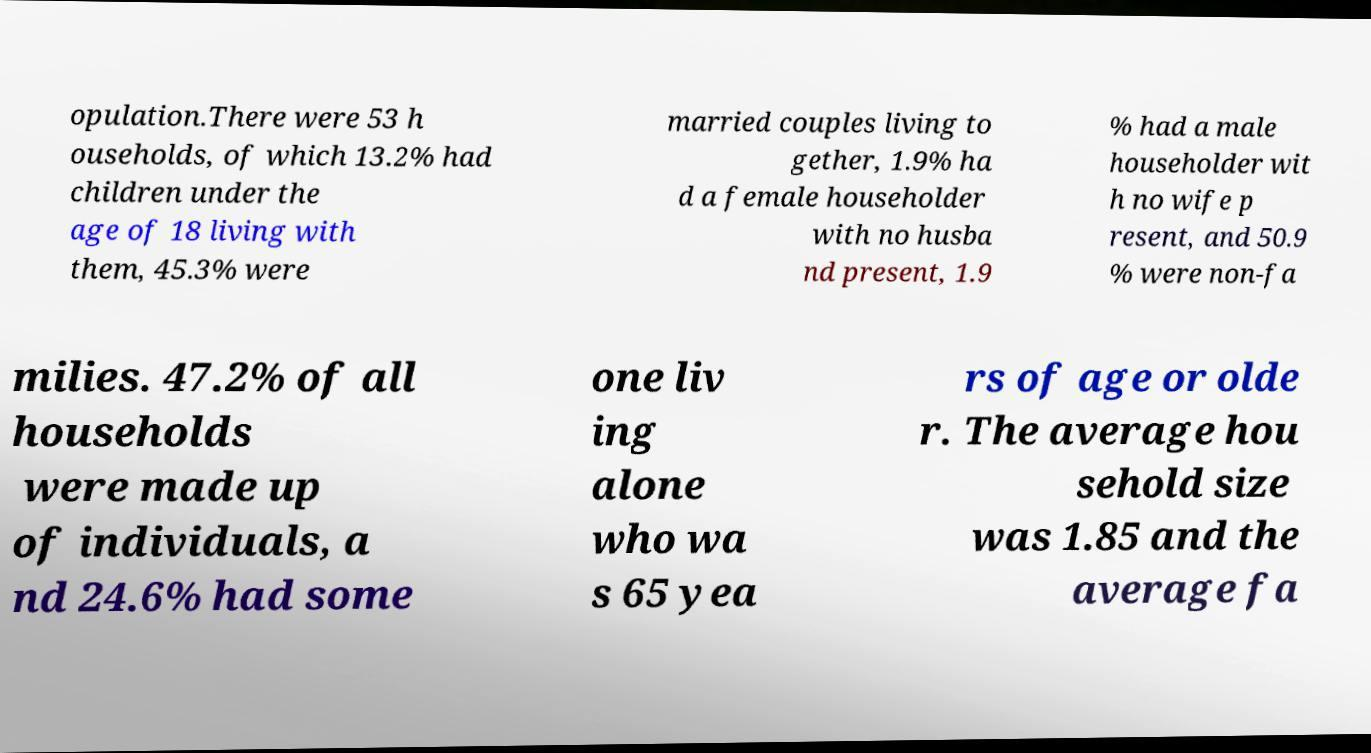Can you read and provide the text displayed in the image?This photo seems to have some interesting text. Can you extract and type it out for me? opulation.There were 53 h ouseholds, of which 13.2% had children under the age of 18 living with them, 45.3% were married couples living to gether, 1.9% ha d a female householder with no husba nd present, 1.9 % had a male householder wit h no wife p resent, and 50.9 % were non-fa milies. 47.2% of all households were made up of individuals, a nd 24.6% had some one liv ing alone who wa s 65 yea rs of age or olde r. The average hou sehold size was 1.85 and the average fa 